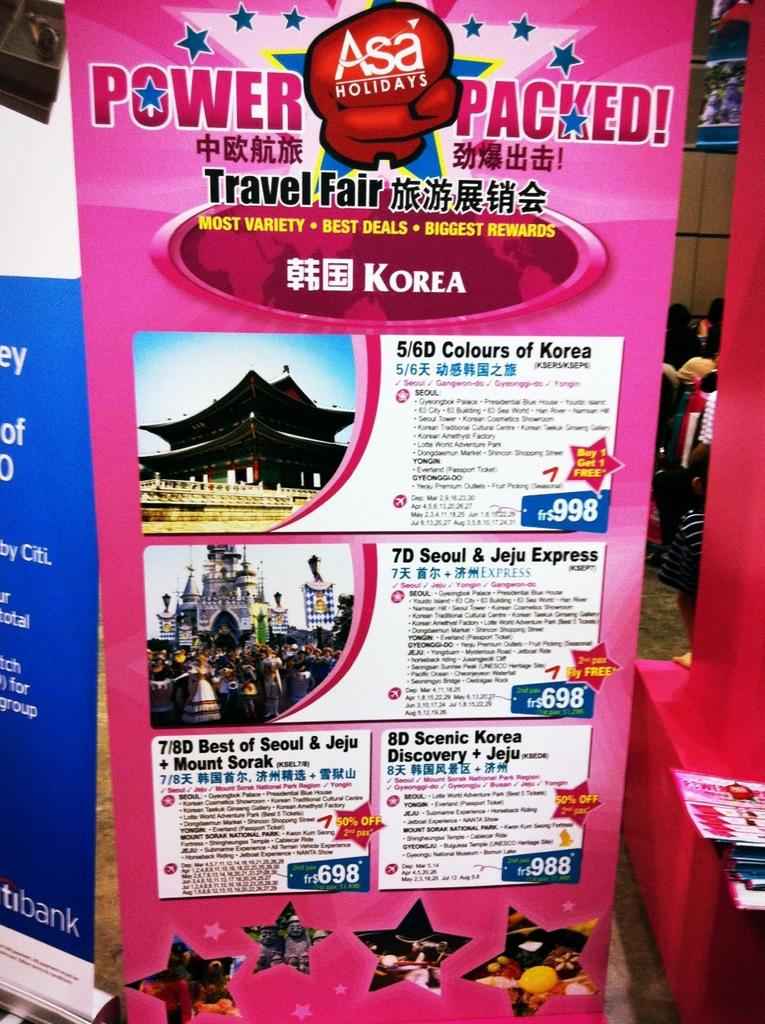<image>
Share a concise interpretation of the image provided. A travel poster titled Power Packed advertises several holiday offerings. 